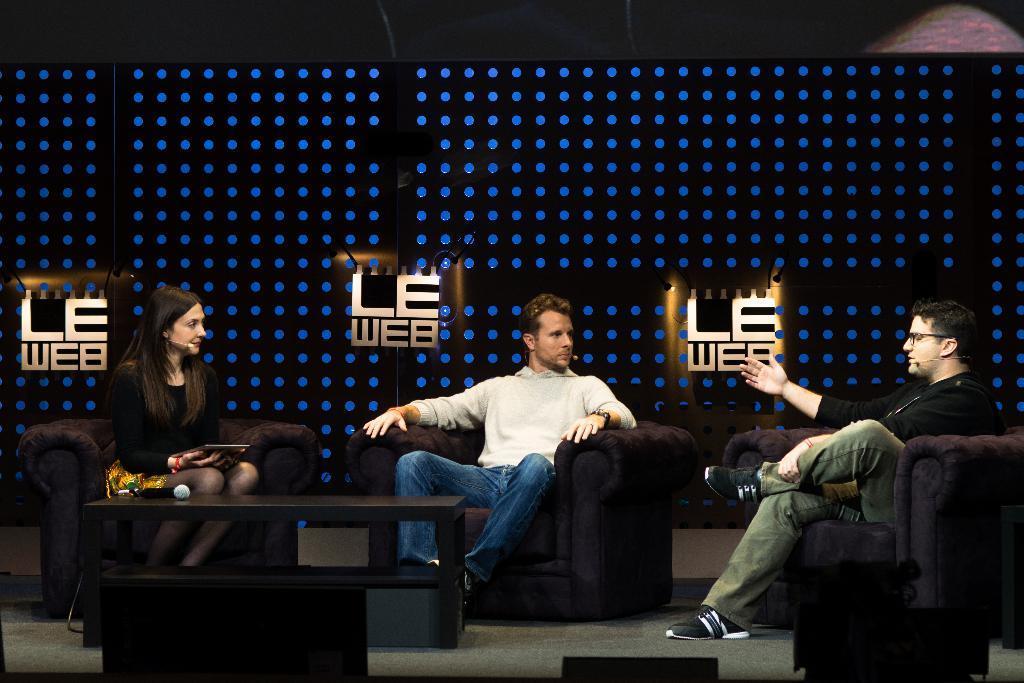Please provide a concise description of this image. The photo is taken inside a room. There are three persons sitting on couch. There is a table in front of them. On the table there is a mic. On the right side a man wearing black t shirt and pant is talking something to the other two persons in front of him. in the middle a man who is wearing white shirt is looking at the person left to him. On the left there is a woman wearing black dress. She is looking at the person in front of her. in the background there are lights and logos. on the logo it is written LEWAP. 